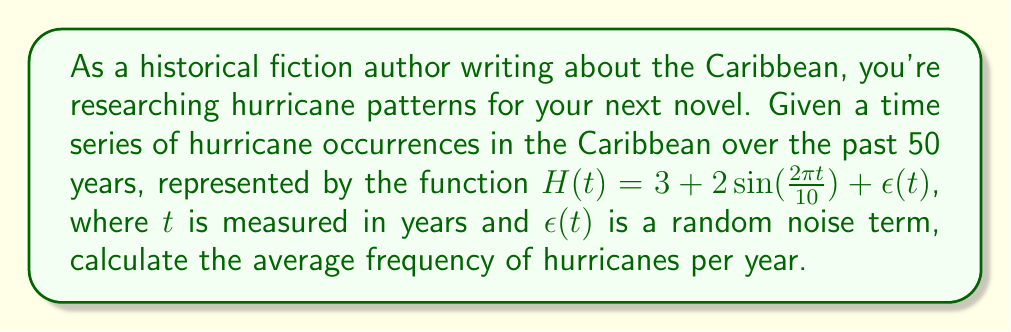Could you help me with this problem? To solve this problem, we'll follow these steps:

1) The given function $H(t)$ represents the number of hurricanes in a year $t$. It consists of three parts:
   - A constant term: 3
   - A sinusoidal term: $2\sin(\frac{2\pi t}{10})$
   - A random noise term: $\epsilon(t)$

2) The sinusoidal term represents the cyclical nature of hurricane occurrences, with a period of 10 years.

3) To find the average frequency, we need to calculate the average value of $H(t)$ over a long period, which will eliminate the effects of both the sinusoidal term and the random noise.

4) The average of a sine function over its full period is zero. Therefore, over a long time, the sinusoidal term will average to zero.

5) Similarly, assuming $\epsilon(t)$ is a zero-mean noise, its average over a long time will also be zero.

6) This leaves us with only the constant term, 3, which represents the average number of hurricanes per year.

Therefore, the average frequency of hurricanes per year in the Caribbean, according to this model, is 3.
Answer: 3 hurricanes per year 